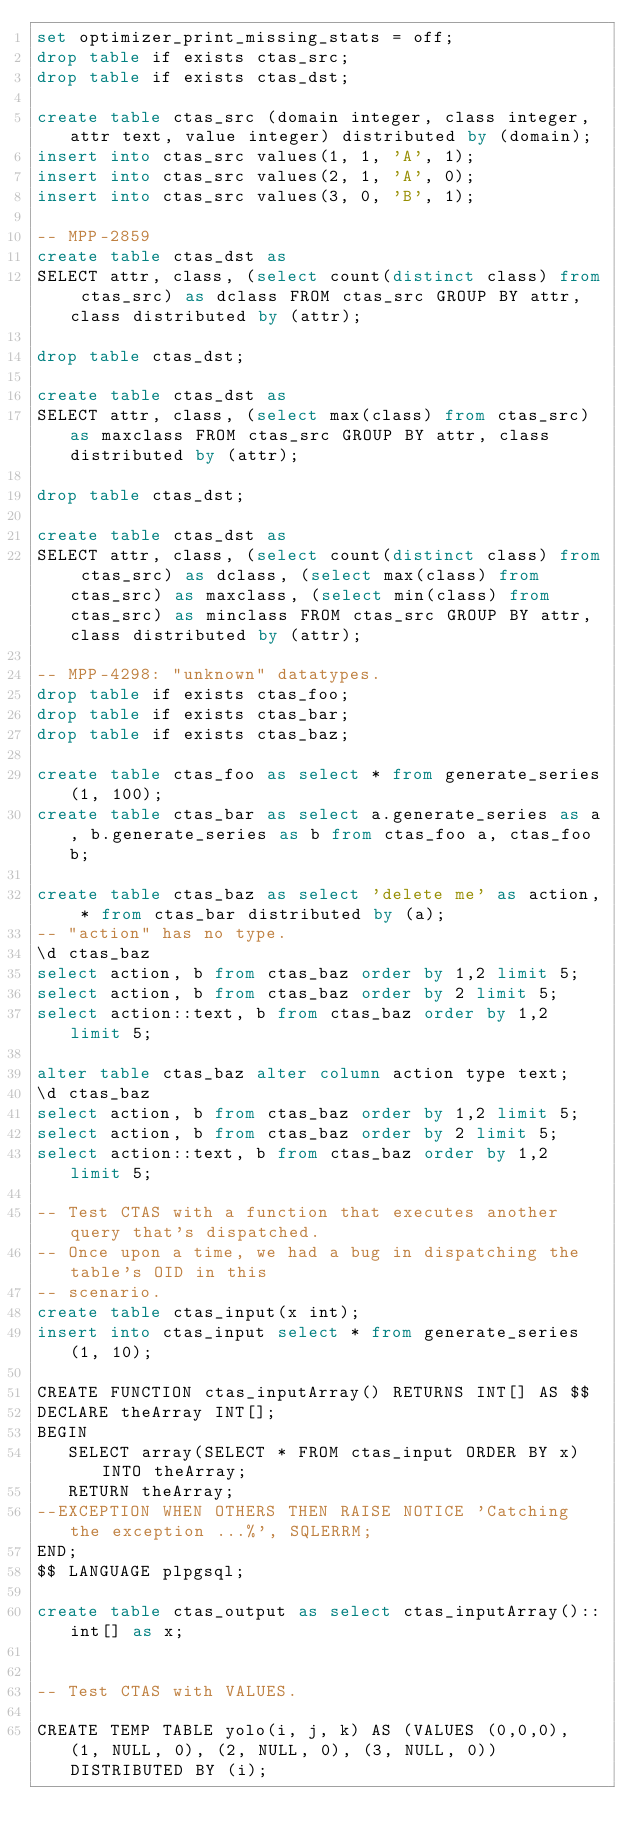Convert code to text. <code><loc_0><loc_0><loc_500><loc_500><_SQL_>set optimizer_print_missing_stats = off;
drop table if exists ctas_src;
drop table if exists ctas_dst;

create table ctas_src (domain integer, class integer, attr text, value integer) distributed by (domain);
insert into ctas_src values(1, 1, 'A', 1);
insert into ctas_src values(2, 1, 'A', 0);
insert into ctas_src values(3, 0, 'B', 1);

-- MPP-2859
create table ctas_dst as 
SELECT attr, class, (select count(distinct class) from ctas_src) as dclass FROM ctas_src GROUP BY attr, class distributed by (attr);

drop table ctas_dst;

create table ctas_dst as 
SELECT attr, class, (select max(class) from ctas_src) as maxclass FROM ctas_src GROUP BY attr, class distributed by (attr);

drop table ctas_dst;

create table ctas_dst as 
SELECT attr, class, (select count(distinct class) from ctas_src) as dclass, (select max(class) from ctas_src) as maxclass, (select min(class) from ctas_src) as minclass FROM ctas_src GROUP BY attr, class distributed by (attr);

-- MPP-4298: "unknown" datatypes.
drop table if exists ctas_foo;
drop table if exists ctas_bar;
drop table if exists ctas_baz;

create table ctas_foo as select * from generate_series(1, 100);
create table ctas_bar as select a.generate_series as a, b.generate_series as b from ctas_foo a, ctas_foo b;

create table ctas_baz as select 'delete me' as action, * from ctas_bar distributed by (a);
-- "action" has no type.
\d ctas_baz
select action, b from ctas_baz order by 1,2 limit 5;
select action, b from ctas_baz order by 2 limit 5;
select action::text, b from ctas_baz order by 1,2 limit 5;

alter table ctas_baz alter column action type text;
\d ctas_baz
select action, b from ctas_baz order by 1,2 limit 5;
select action, b from ctas_baz order by 2 limit 5;
select action::text, b from ctas_baz order by 1,2 limit 5;

-- Test CTAS with a function that executes another query that's dispatched.
-- Once upon a time, we had a bug in dispatching the table's OID in this
-- scenario.
create table ctas_input(x int);
insert into ctas_input select * from generate_series(1, 10);

CREATE FUNCTION ctas_inputArray() RETURNS INT[] AS $$
DECLARE theArray INT[];
BEGIN
   SELECT array(SELECT * FROM ctas_input ORDER BY x) INTO theArray;
   RETURN theArray;
--EXCEPTION WHEN OTHERS THEN RAISE NOTICE 'Catching the exception ...%', SQLERRM;
END;
$$ LANGUAGE plpgsql;

create table ctas_output as select ctas_inputArray()::int[] as x;


-- Test CTAS with VALUES.

CREATE TEMP TABLE yolo(i, j, k) AS (VALUES (0,0,0), (1, NULL, 0), (2, NULL, 0), (3, NULL, 0)) DISTRIBUTED BY (i);
</code> 